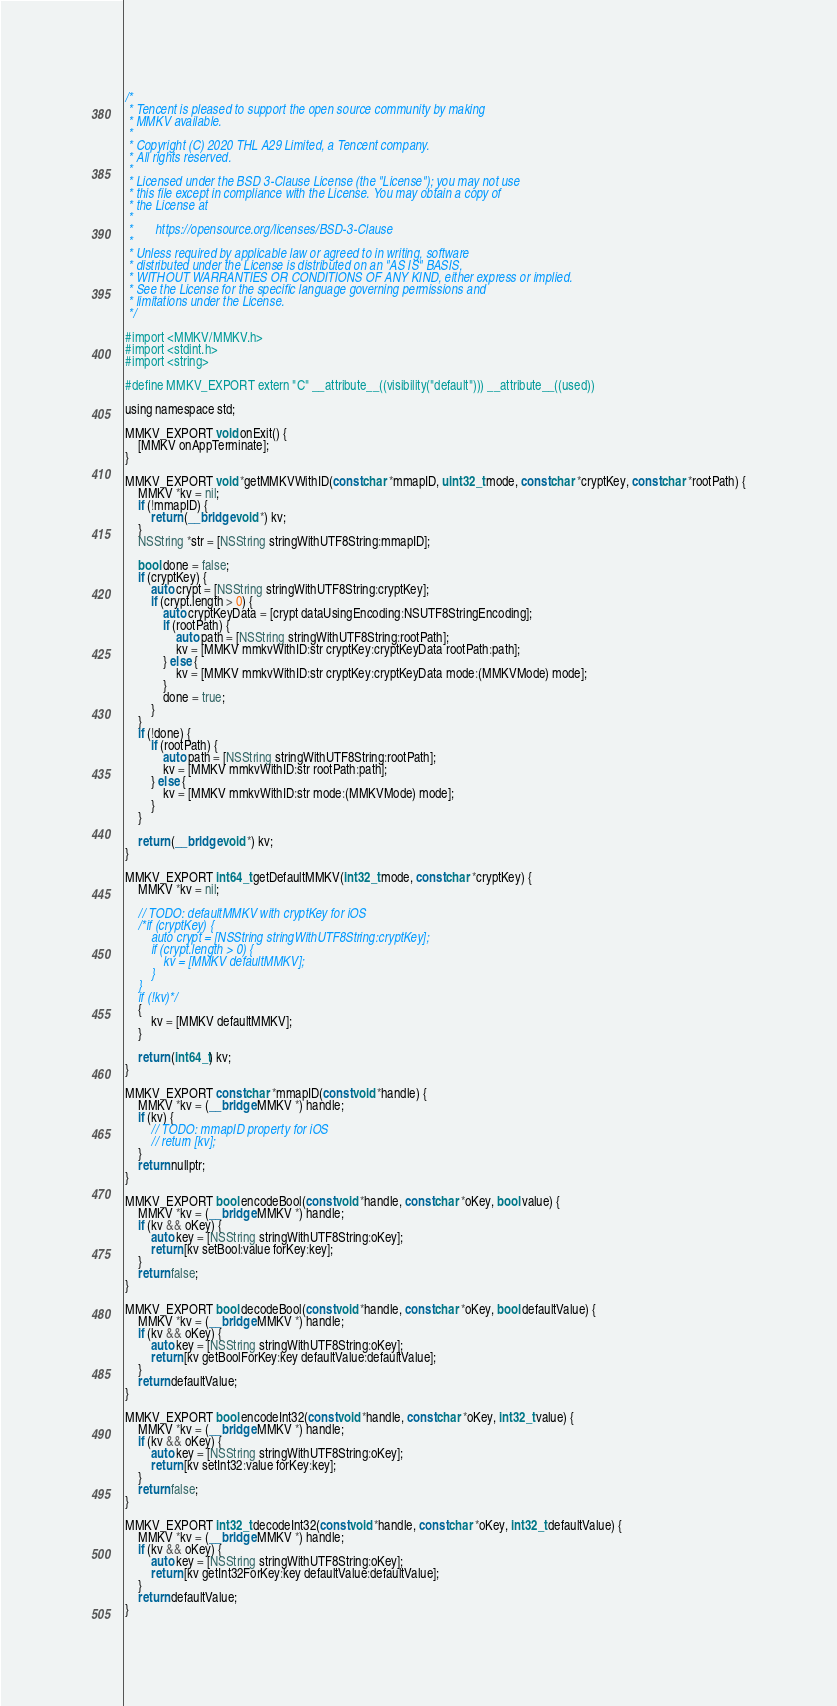<code> <loc_0><loc_0><loc_500><loc_500><_ObjectiveC_>/*
 * Tencent is pleased to support the open source community by making
 * MMKV available.
 *
 * Copyright (C) 2020 THL A29 Limited, a Tencent company.
 * All rights reserved.
 *
 * Licensed under the BSD 3-Clause License (the "License"); you may not use
 * this file except in compliance with the License. You may obtain a copy of
 * the License at
 *
 *       https://opensource.org/licenses/BSD-3-Clause
 *
 * Unless required by applicable law or agreed to in writing, software
 * distributed under the License is distributed on an "AS IS" BASIS,
 * WITHOUT WARRANTIES OR CONDITIONS OF ANY KIND, either express or implied.
 * See the License for the specific language governing permissions and
 * limitations under the License.
 */

#import <MMKV/MMKV.h>
#import <stdint.h>
#import <string>

#define MMKV_EXPORT extern "C" __attribute__((visibility("default"))) __attribute__((used))

using namespace std;

MMKV_EXPORT void onExit() {
    [MMKV onAppTerminate];
}

MMKV_EXPORT void *getMMKVWithID(const char *mmapID, uint32_t mode, const char *cryptKey, const char *rootPath) {
    MMKV *kv = nil;
    if (!mmapID) {
        return (__bridge void *) kv;
    }
    NSString *str = [NSString stringWithUTF8String:mmapID];

    bool done = false;
    if (cryptKey) {
        auto crypt = [NSString stringWithUTF8String:cryptKey];
        if (crypt.length > 0) {
            auto cryptKeyData = [crypt dataUsingEncoding:NSUTF8StringEncoding];
            if (rootPath) {
                auto path = [NSString stringWithUTF8String:rootPath];
                kv = [MMKV mmkvWithID:str cryptKey:cryptKeyData rootPath:path];
            } else {
                kv = [MMKV mmkvWithID:str cryptKey:cryptKeyData mode:(MMKVMode) mode];
            }
            done = true;
        }
    }
    if (!done) {
        if (rootPath) {
            auto path = [NSString stringWithUTF8String:rootPath];
            kv = [MMKV mmkvWithID:str rootPath:path];
        } else {
            kv = [MMKV mmkvWithID:str mode:(MMKVMode) mode];
        }
    }

    return (__bridge void *) kv;
}

MMKV_EXPORT int64_t getDefaultMMKV(int32_t mode, const char *cryptKey) {
    MMKV *kv = nil;

    // TODO: defaultMMKV with cryptKey for iOS
    /*if (cryptKey) {
        auto crypt = [NSString stringWithUTF8String:cryptKey];
        if (crypt.length > 0) {
            kv = [MMKV defaultMMKV];
        }
    }
    if (!kv)*/
    {
        kv = [MMKV defaultMMKV];
    }

    return (int64_t) kv;
}

MMKV_EXPORT const char *mmapID(const void *handle) {
    MMKV *kv = (__bridge MMKV *) handle;
    if (kv) {
        // TODO: mmapID property for iOS
        // return [kv];
    }
    return nullptr;
}

MMKV_EXPORT bool encodeBool(const void *handle, const char *oKey, bool value) {
    MMKV *kv = (__bridge MMKV *) handle;
    if (kv && oKey) {
        auto key = [NSString stringWithUTF8String:oKey];
        return [kv setBool:value forKey:key];
    }
    return false;
}

MMKV_EXPORT bool decodeBool(const void *handle, const char *oKey, bool defaultValue) {
    MMKV *kv = (__bridge MMKV *) handle;
    if (kv && oKey) {
        auto key = [NSString stringWithUTF8String:oKey];
        return [kv getBoolForKey:key defaultValue:defaultValue];
    }
    return defaultValue;
}

MMKV_EXPORT bool encodeInt32(const void *handle, const char *oKey, int32_t value) {
    MMKV *kv = (__bridge MMKV *) handle;
    if (kv && oKey) {
        auto key = [NSString stringWithUTF8String:oKey];
        return [kv setInt32:value forKey:key];
    }
    return false;
}

MMKV_EXPORT int32_t decodeInt32(const void *handle, const char *oKey, int32_t defaultValue) {
    MMKV *kv = (__bridge MMKV *) handle;
    if (kv && oKey) {
        auto key = [NSString stringWithUTF8String:oKey];
        return [kv getInt32ForKey:key defaultValue:defaultValue];
    }
    return defaultValue;
}
</code> 